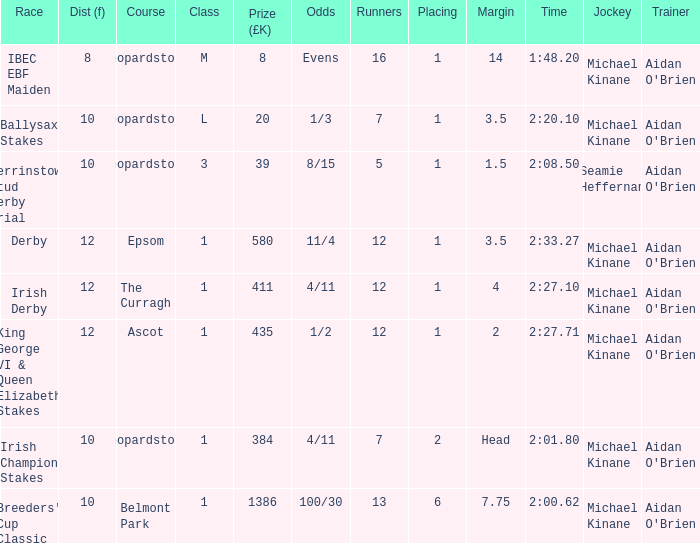Which Race has a Runners of 7 and Odds of 1/3? Ballysax Stakes. 